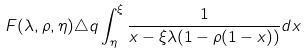Convert formula to latex. <formula><loc_0><loc_0><loc_500><loc_500>F ( \lambda , \rho , \eta ) \triangle q \int _ { \eta } ^ { \xi } \frac { 1 } { x - \xi \lambda ( 1 - \rho ( 1 - x ) ) } d x</formula> 